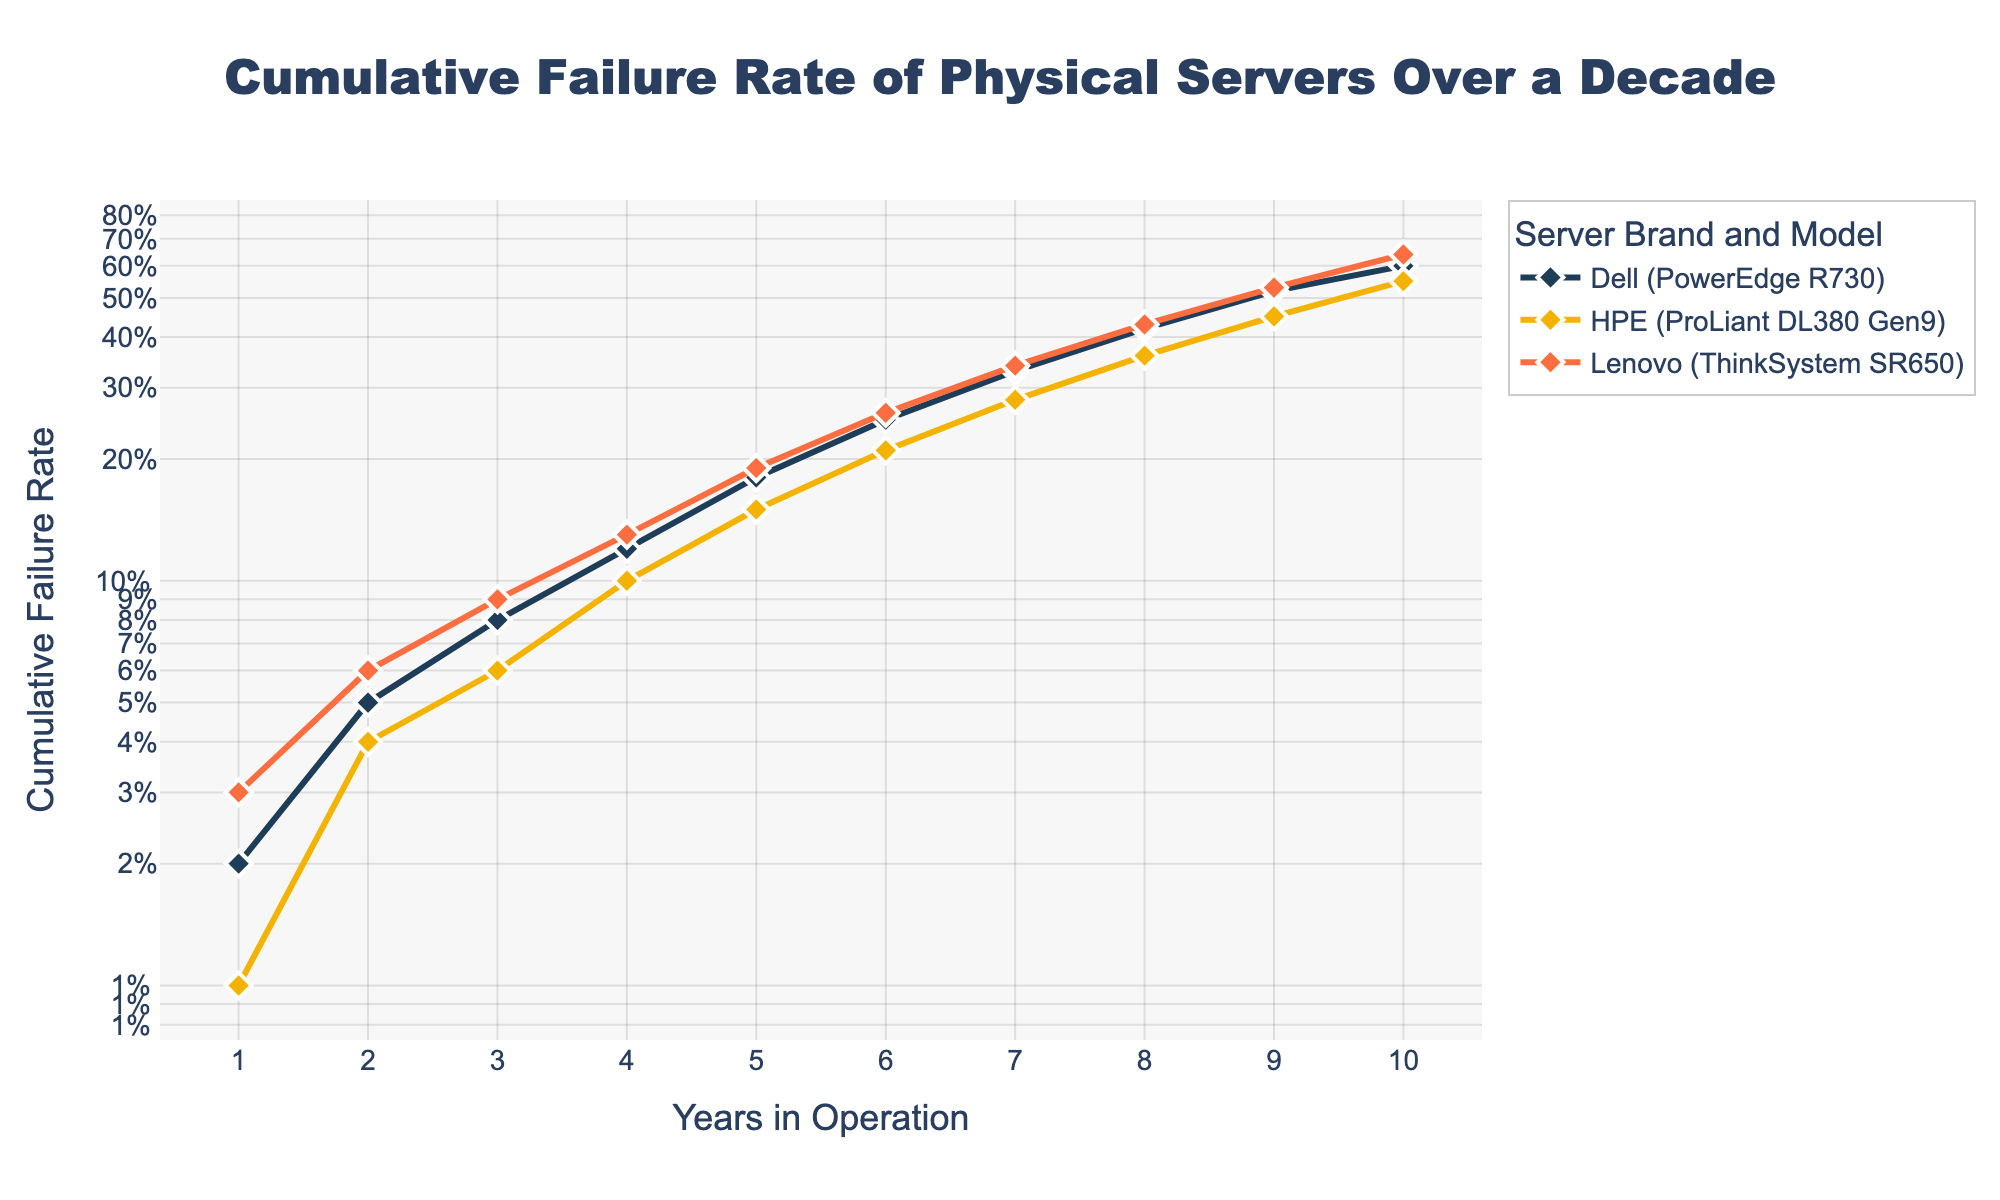What is the title of the chart? The title of the chart is located at the top of the figure and it reads, "Cumulative Failure Rate of Physical Servers Over a Decade". This can be identified by its prominent placement and larger font size.
Answer: Cumulative Failure Rate of Physical Servers Over a Decade Which server model has the highest Cumulative Failure Rate at 10 years? The plot shows three lines, each representing a different server model. By looking at the 10-year mark on the x-axis and finding the highest point on the y-axis among the three lines, we can identify the server model with the highest failure rate. It is the Lenovo ThinkSystem SR650.
Answer: Lenovo ThinkSystem SR650 What is the Cumulative Failure Rate of Dell PowerEdge R730 at 5 years? The plot has markers indicating the Cumulative Failure Rates at each year. Locate the Dell PowerEdge R730 line and find the marker at the 5-year interval. The corresponding y-axis value is 18%.
Answer: 18% Which server brand shows the most rapid increase in Cumulative Failure Rate between years 1 and 10? By comparing the slopes of the lines representing each server brand from year 1 to year 10, we observe that Lenovo's ThinkSystem SR650 shows the steepest gradient, indicating the most rapid increase in failure rate.
Answer: Lenovo How much more is the Cumulative Failure Rate for Lenovo ThinkSystem SR650 compared to Dell PowerEdge R730 at year 8? To find the difference, look at the y-axis values for both models at the 8-year mark. Lenovo ThinkSystem SR650 has a Cumulative Failure Rate of 43%, and Dell PowerEdge R730 has 42%. Subtract 42% from 43% to get 1%.
Answer: 1% What is the lowest Cumulative Failure Rate recorded for any server model? Examine the plot for the minimum point on the y-axis across all lines and all years. The lowest value at year 1 for HPE ProLiant DL380 Gen9 is 1%.
Answer: 1% How do the trends of HPE ProLiant DL380 Gen9 and Dell PowerEdge R730 lines compare over the first 5 years? Observing the two lines over the first 5 years, HPE ProLiant DL380 Gen9 starts lower and increases more gently than Dell PowerEdge R730. Both show an increasing trend, but Dell PowerEdge R730 reaches 18% while HPE ProLiant DL380 Gen9 reaches 15% at year 5.
Answer: HPE's increase is gentler What can be said about the reliability of HPE ProLiant DL380 Gen9 compared to Lenovo ThinkSystem SR650 after 6 years? At the 6-year mark, comparing both lines, the Cumulative Failure Rate for HPE ProLiant DL380 Gen9 is 21%, whereas for Lenovo ThinkSystem SR650 it is 26%. HPE ProLiant DL380 Gen9 has a lower failure rate, indicating better reliability.
Answer: HPE is more reliable Is there a point where the Cumulative Failure Rate of Dell PowerEdge R730 and HPE ProLiant DL380 Gen9 are equal? By examining the overlap of the lines, we see that there is no point where the Cumulative Failure Rates of Dell PowerEdge R730 and HPE ProLiant DL380 Gen9 lines are exactly the same.
Answer: No Which server model shows the least variation in its Cumulative Failure Rate over the years? Visualizing the smoothness and tight range of the lines, HPE ProLiant DL380 Gen9 shows the least variation with a much smoother and less steep line compared to the others.
Answer: HPE ProLiant DL380 Gen9 